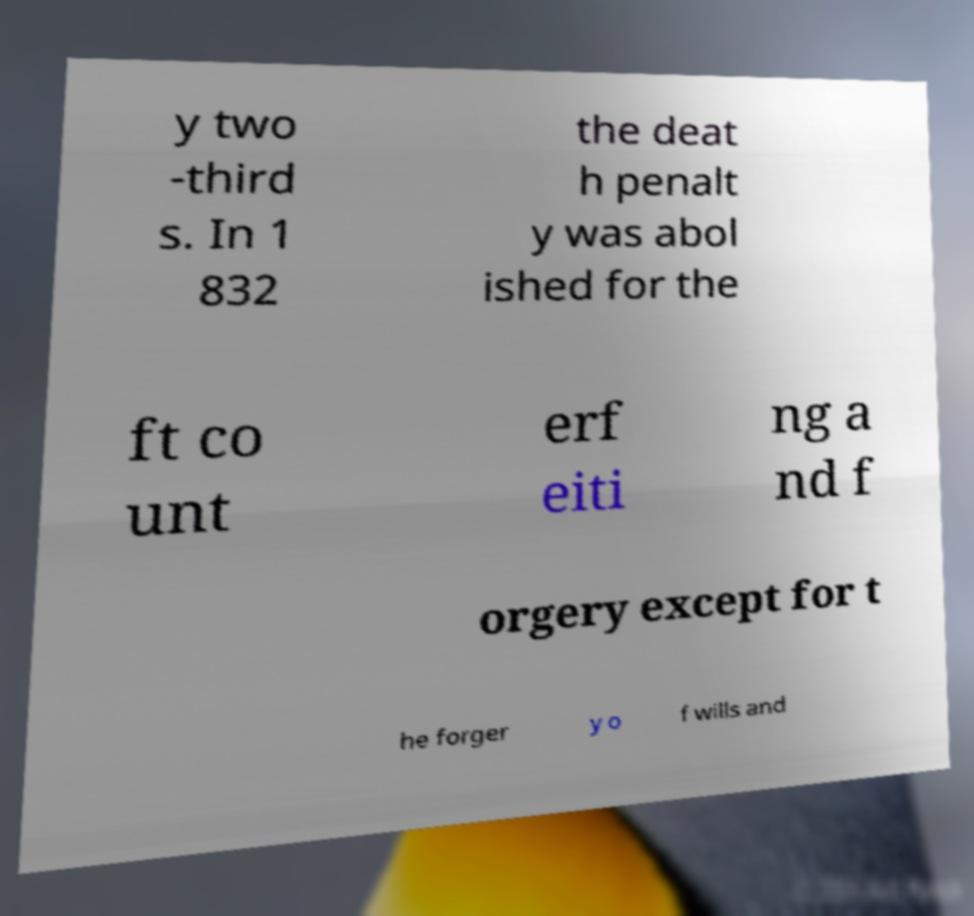Could you extract and type out the text from this image? y two -third s. In 1 832 the deat h penalt y was abol ished for the ft co unt erf eiti ng a nd f orgery except for t he forger y o f wills and 